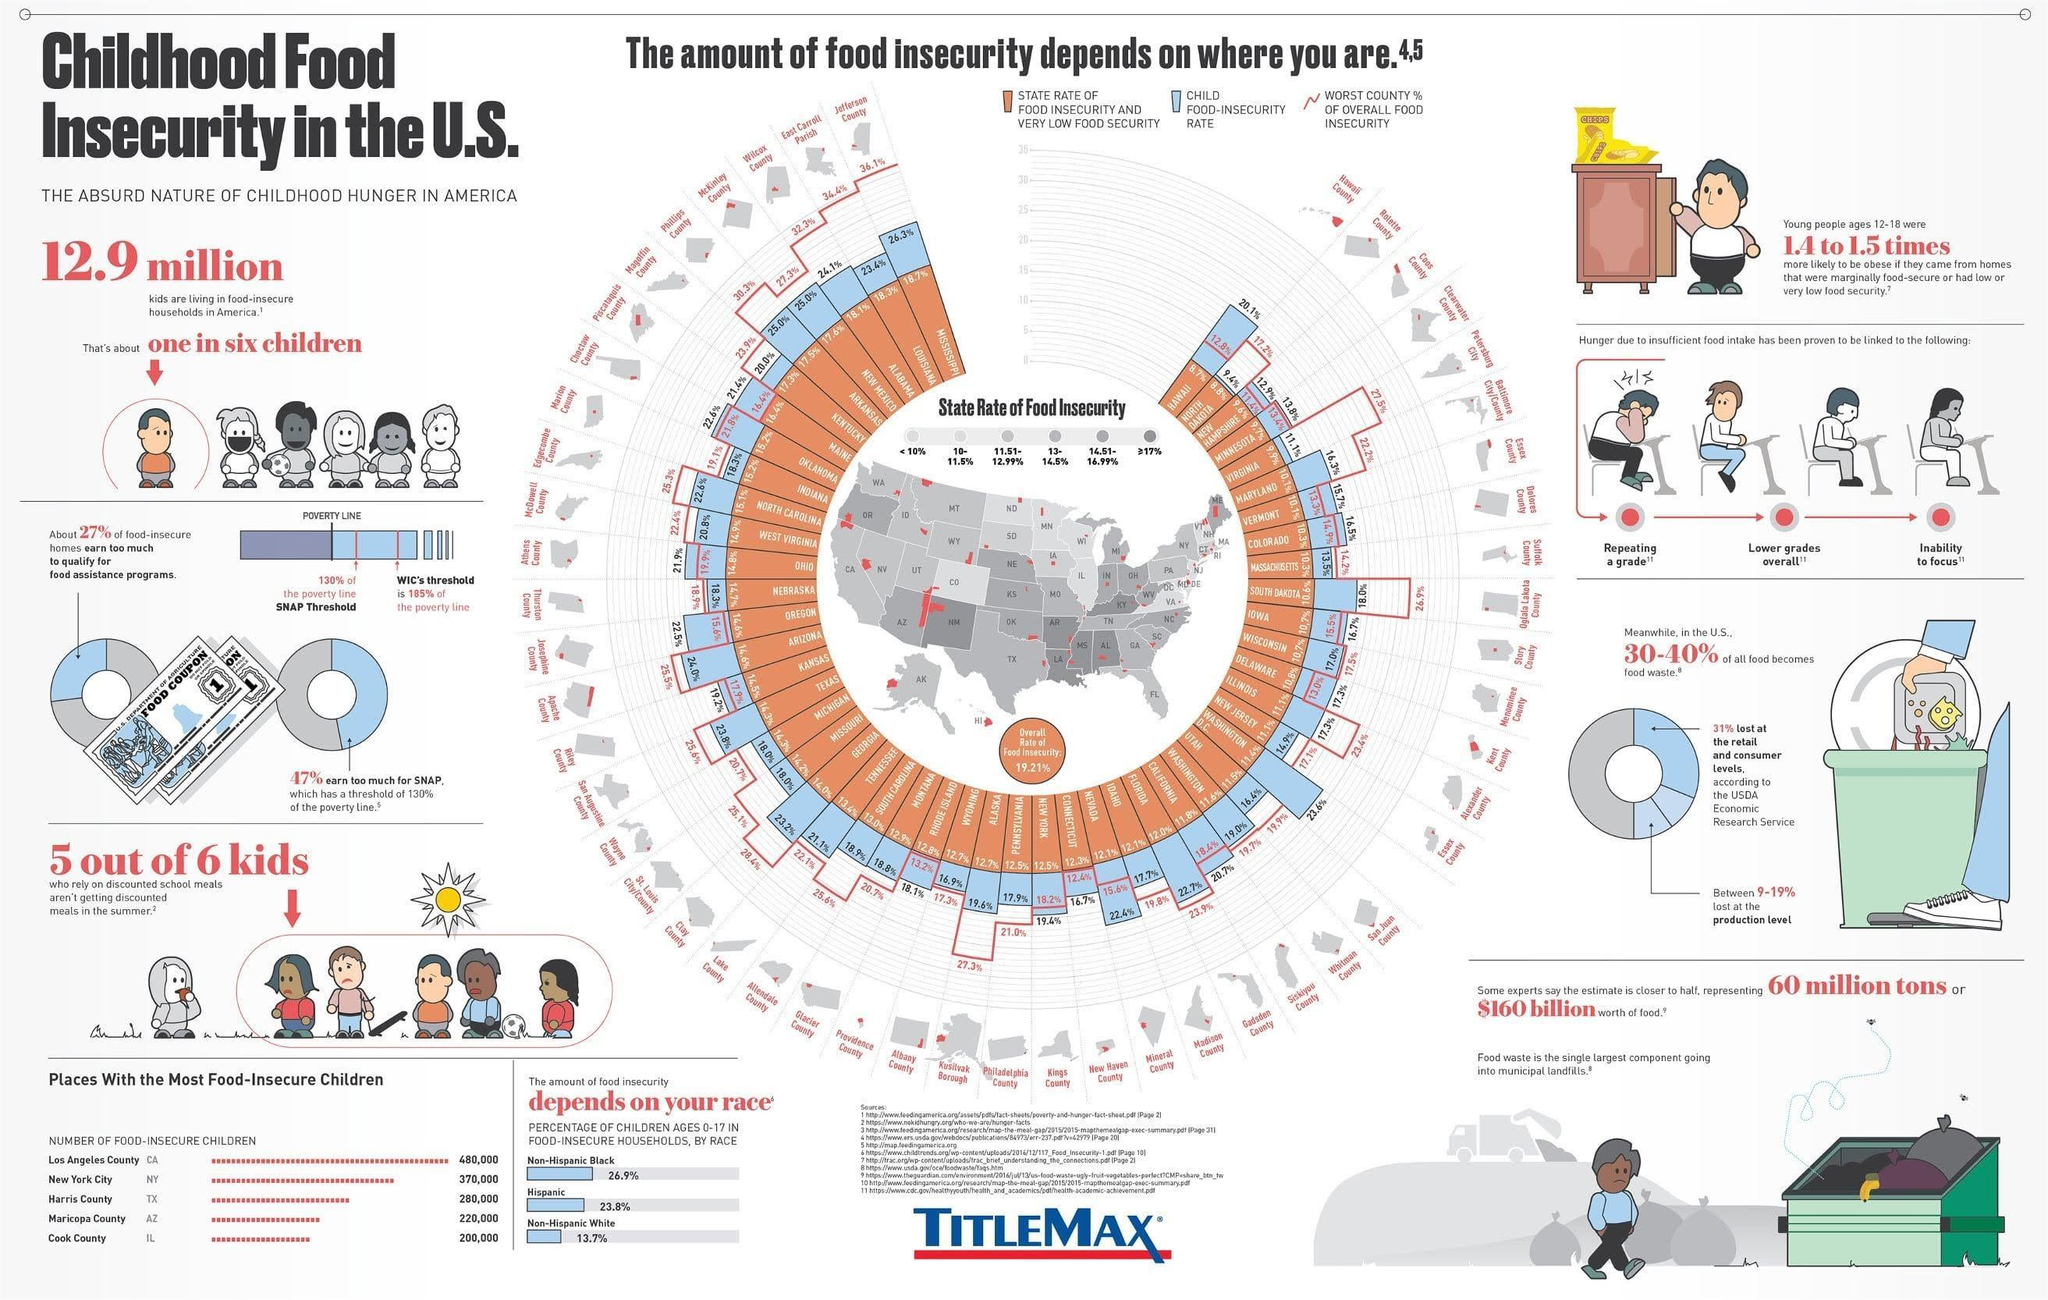How many different races are listed in the info graphic?
Answer the question with a short phrase. 3 What is the Child Food Insecurity rate of New Mexico? 25.0% What is the State rate of Food Insecurity of Ohio? 14.8% What is the Child Food Insecurity rate of Mississippi? 26.3% What is the Worst County % of Overall Food security for the country Hawaii? 12.8% What is the Child Food Insecurity rate of Colorado? 16.5% The place with second lowest number of Food Insecure children? Maricopa County 